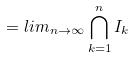<formula> <loc_0><loc_0><loc_500><loc_500>= l i m _ { n \rightarrow \infty } \bigcap _ { k = 1 } ^ { n } I _ { k }</formula> 